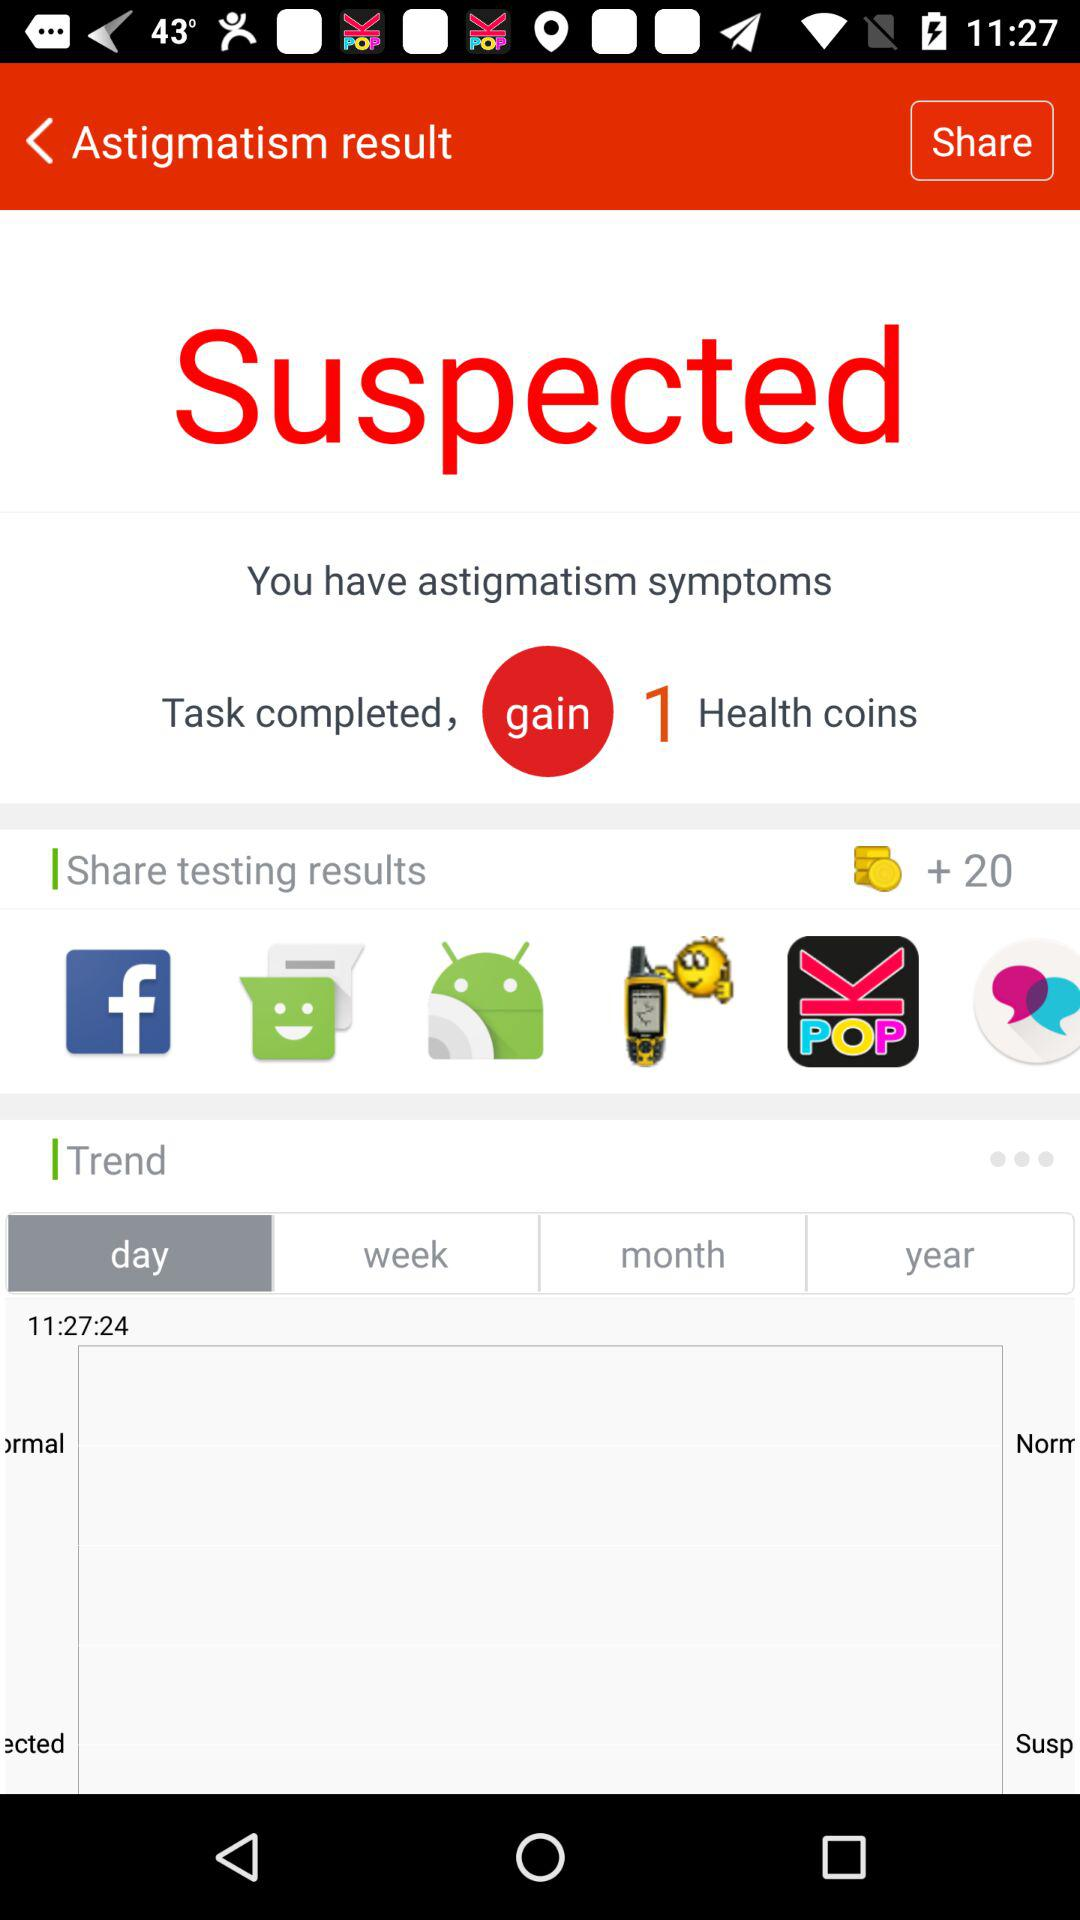What applications can be used to share testing results? The applications that can be used to share testing results are "Facebook", "Messaging", "Android Beam", "KPOP Amino for K-Pop Entertainment" and "Tandem: Language exchange". 